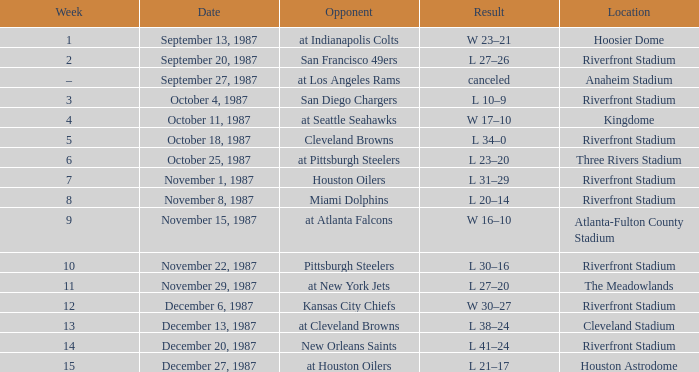What was the result of the game against the Miami Dolphins held at the Riverfront Stadium? L 20–14. 